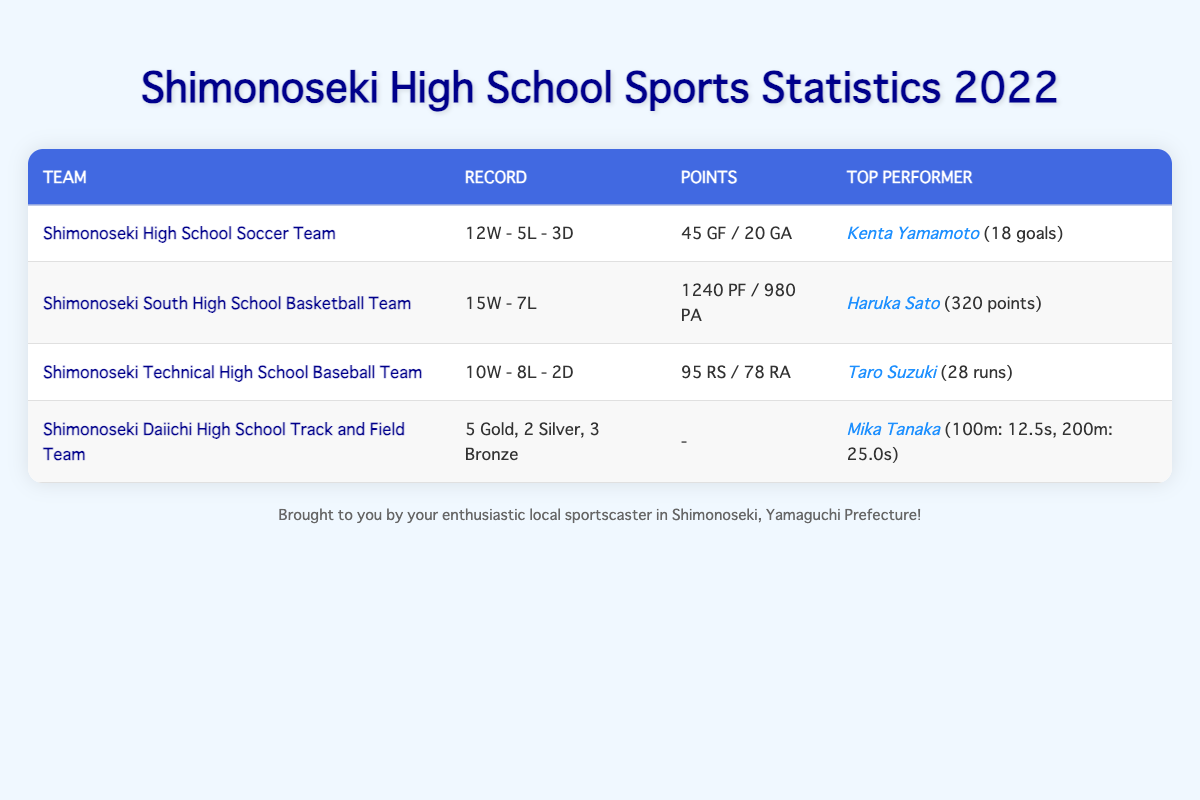What is the total number of wins for Shimonoseki High School sports teams in 2022? To find the total wins, I will add up the wins from each team: Soccer Team (12) + Basketball Team (15) + Baseball Team (10) + Track and Field Team (0) = 37.
Answer: 37 Who scored the most goals in the soccer team? The top scorer of the Shimonoseki High School Soccer Team is Kenta Yamamoto with 18 goals.
Answer: Kenta Yamamoto Did Shimonoseki Technical High School's baseball team have more wins than losses? The baseball team had 10 wins and 8 losses, which means they had more wins than losses.
Answer: Yes What was the win-loss record of the Shimonoseki South High School Basketball Team? The basketball team's record is 15 wins and 7 losses, which is shown directly in the table under the "Record" column.
Answer: 15W - 7L How many total medals did Shimonoseki Daiichi High School Track and Field Team win? To find the total medals, I will add gold (5), silver (2), and bronze (3): 5 + 2 + 3 = 10 medals.
Answer: 10 medals Which sports team had the highest points scored? The Shimonoseki South High School Basketball Team scored 1240 points, which is the highest among all teams listed.
Answer: Shimonoseki South High School Basketball Team Is Taro Suzuki the top scorer for the baseball team? Yes, Taro Suzuki is the top scorer for the Shimonoseki Technical High School Baseball Team with 28 runs.
Answer: Yes Which team had the best record in terms of wins? The team with the best record in terms of wins is the Shimonoseki South High School Basketball Team with 15 wins.
Answer: Shimonoseki South High School Basketball Team What is the average number of goals scored by Shimonoseki High School Soccer Team per game played? They played a total of 20 matches (12 wins + 5 losses + 3 draws). The total goals scored is 45. Therefore, the average is 45 goals / 20 matches = 2.25 goals per game.
Answer: 2.25 goals per game 